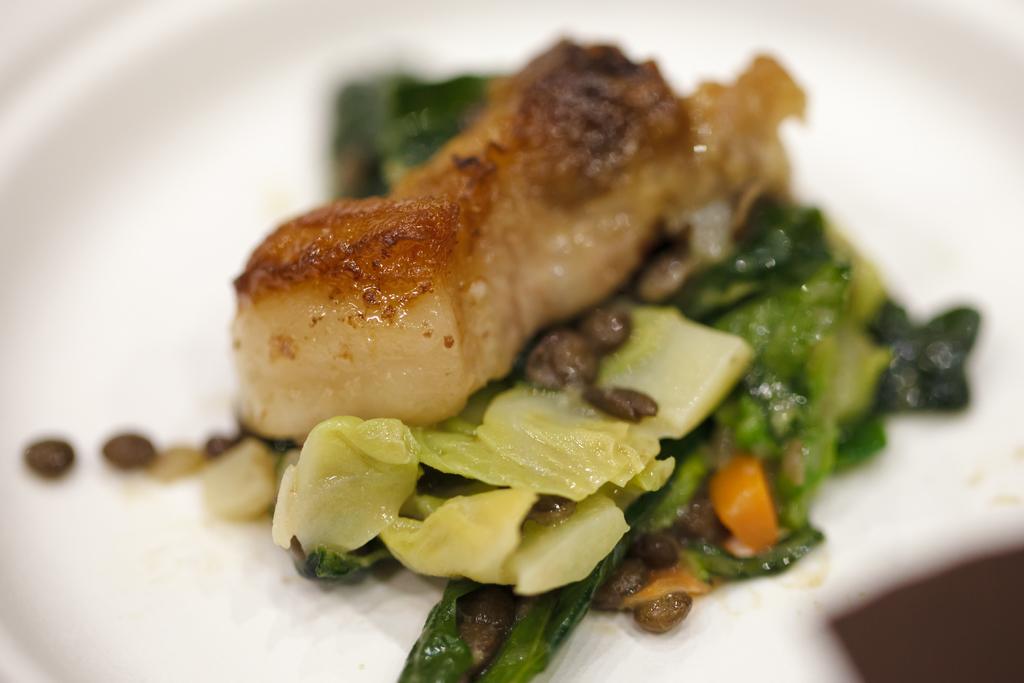How would you summarize this image in a sentence or two? In this picture I can observe some food places in the plate. The plate is in white color. 